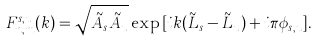<formula> <loc_0><loc_0><loc_500><loc_500>F _ { n , m } ^ { s , u } ( k ) = \sqrt { \tilde { A } _ { s } \tilde { A } _ { u } } \exp { [ i k ( \tilde { L } _ { s } - \tilde { L } _ { u } ) + i \pi \phi _ { s , u } ] } .</formula> 